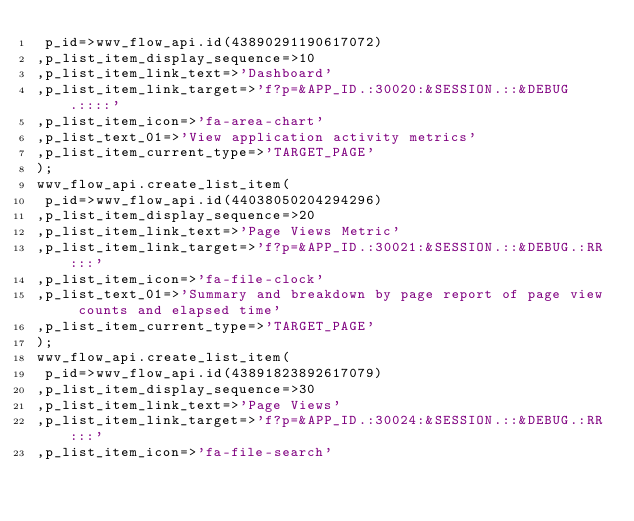<code> <loc_0><loc_0><loc_500><loc_500><_SQL_> p_id=>wwv_flow_api.id(43890291190617072)
,p_list_item_display_sequence=>10
,p_list_item_link_text=>'Dashboard'
,p_list_item_link_target=>'f?p=&APP_ID.:30020:&SESSION.::&DEBUG.::::'
,p_list_item_icon=>'fa-area-chart'
,p_list_text_01=>'View application activity metrics'
,p_list_item_current_type=>'TARGET_PAGE'
);
wwv_flow_api.create_list_item(
 p_id=>wwv_flow_api.id(44038050204294296)
,p_list_item_display_sequence=>20
,p_list_item_link_text=>'Page Views Metric'
,p_list_item_link_target=>'f?p=&APP_ID.:30021:&SESSION.::&DEBUG.:RR:::'
,p_list_item_icon=>'fa-file-clock'
,p_list_text_01=>'Summary and breakdown by page report of page view counts and elapsed time'
,p_list_item_current_type=>'TARGET_PAGE'
);
wwv_flow_api.create_list_item(
 p_id=>wwv_flow_api.id(43891823892617079)
,p_list_item_display_sequence=>30
,p_list_item_link_text=>'Page Views'
,p_list_item_link_target=>'f?p=&APP_ID.:30024:&SESSION.::&DEBUG.:RR:::'
,p_list_item_icon=>'fa-file-search'</code> 